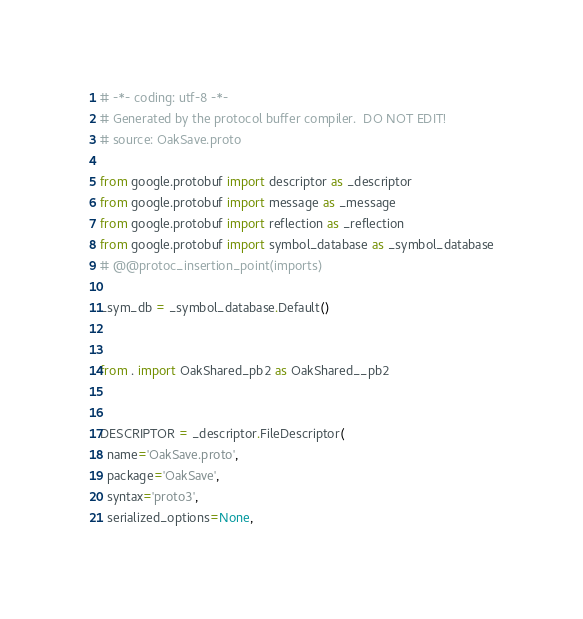<code> <loc_0><loc_0><loc_500><loc_500><_Python_># -*- coding: utf-8 -*-
# Generated by the protocol buffer compiler.  DO NOT EDIT!
# source: OakSave.proto

from google.protobuf import descriptor as _descriptor
from google.protobuf import message as _message
from google.protobuf import reflection as _reflection
from google.protobuf import symbol_database as _symbol_database
# @@protoc_insertion_point(imports)

_sym_db = _symbol_database.Default()


from . import OakShared_pb2 as OakShared__pb2


DESCRIPTOR = _descriptor.FileDescriptor(
  name='OakSave.proto',
  package='OakSave',
  syntax='proto3',
  serialized_options=None,</code> 